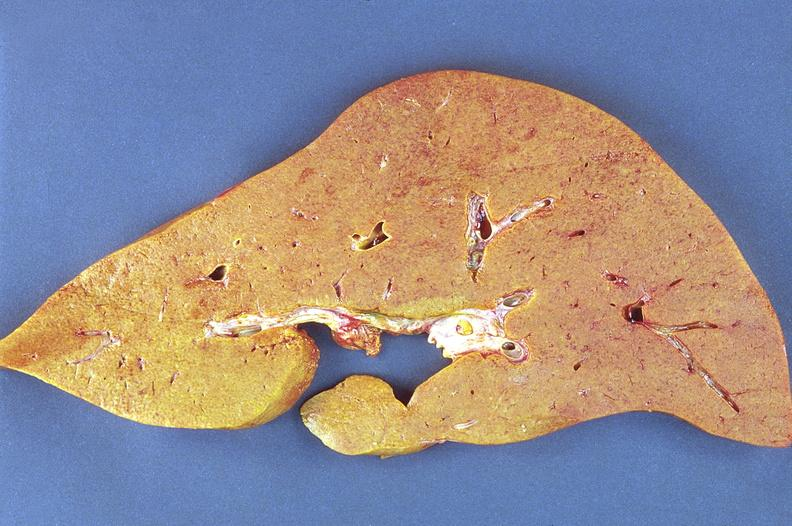s fibrotic lesion present?
Answer the question using a single word or phrase. No 